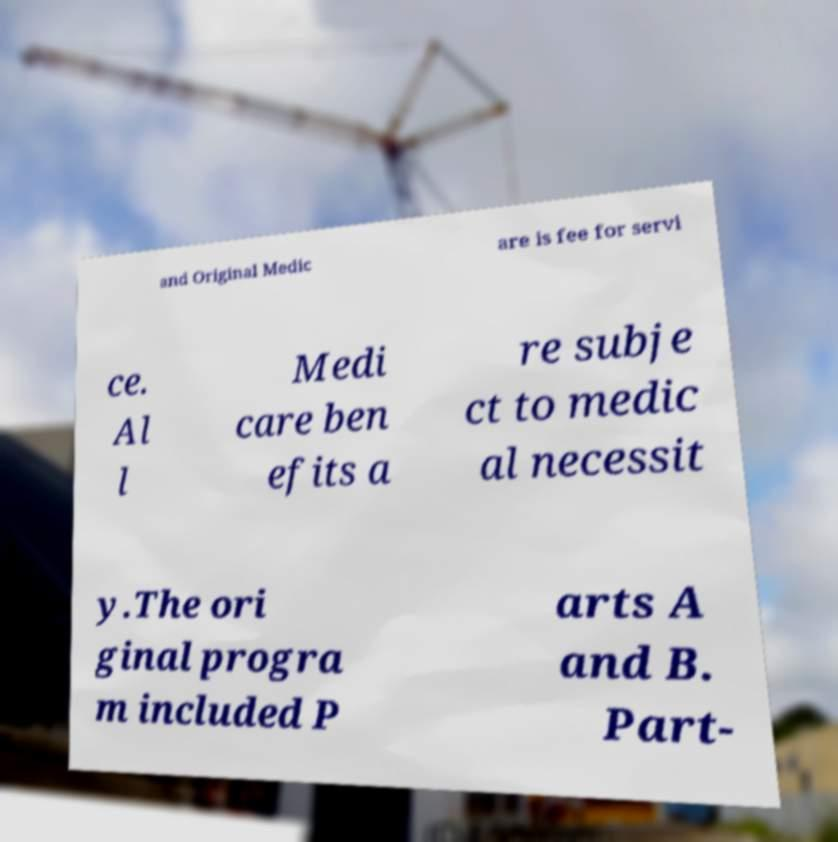There's text embedded in this image that I need extracted. Can you transcribe it verbatim? and Original Medic are is fee for servi ce. Al l Medi care ben efits a re subje ct to medic al necessit y.The ori ginal progra m included P arts A and B. Part- 